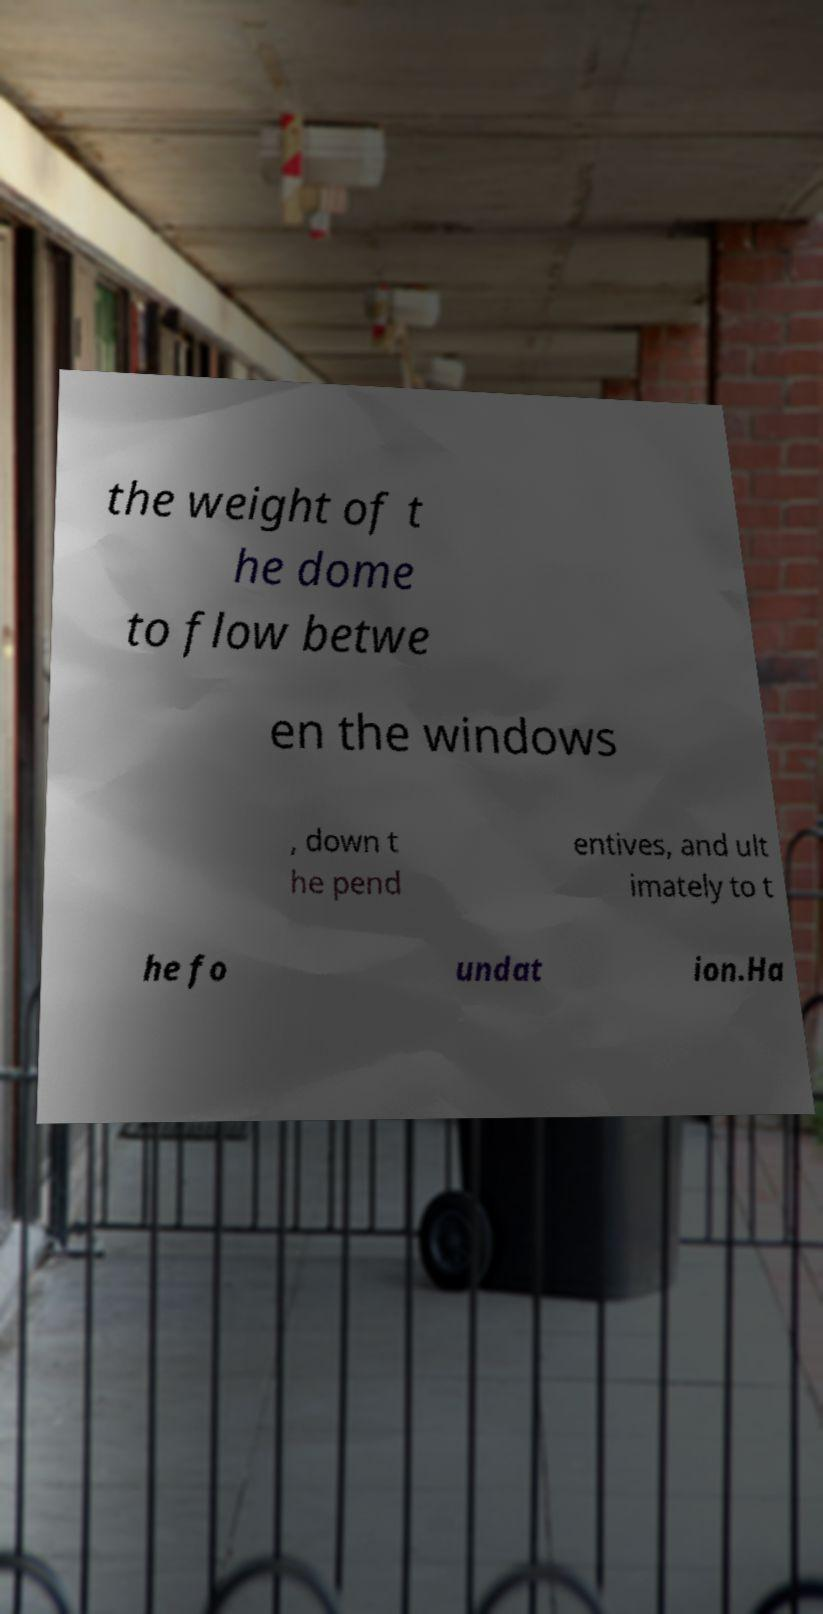Please identify and transcribe the text found in this image. the weight of t he dome to flow betwe en the windows , down t he pend entives, and ult imately to t he fo undat ion.Ha 